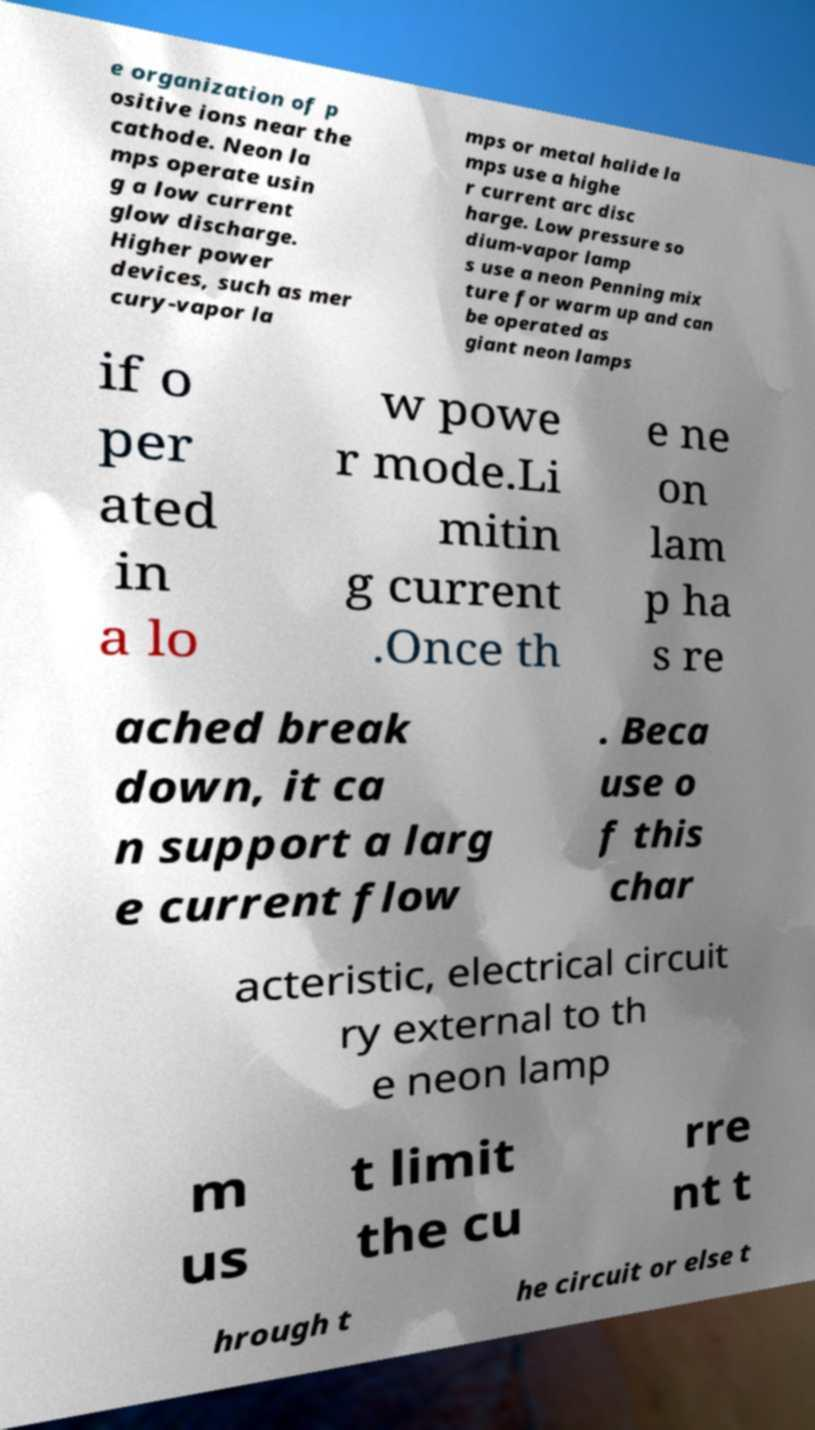Could you assist in decoding the text presented in this image and type it out clearly? e organization of p ositive ions near the cathode. Neon la mps operate usin g a low current glow discharge. Higher power devices, such as mer cury-vapor la mps or metal halide la mps use a highe r current arc disc harge. Low pressure so dium-vapor lamp s use a neon Penning mix ture for warm up and can be operated as giant neon lamps if o per ated in a lo w powe r mode.Li mitin g current .Once th e ne on lam p ha s re ached break down, it ca n support a larg e current flow . Beca use o f this char acteristic, electrical circuit ry external to th e neon lamp m us t limit the cu rre nt t hrough t he circuit or else t 